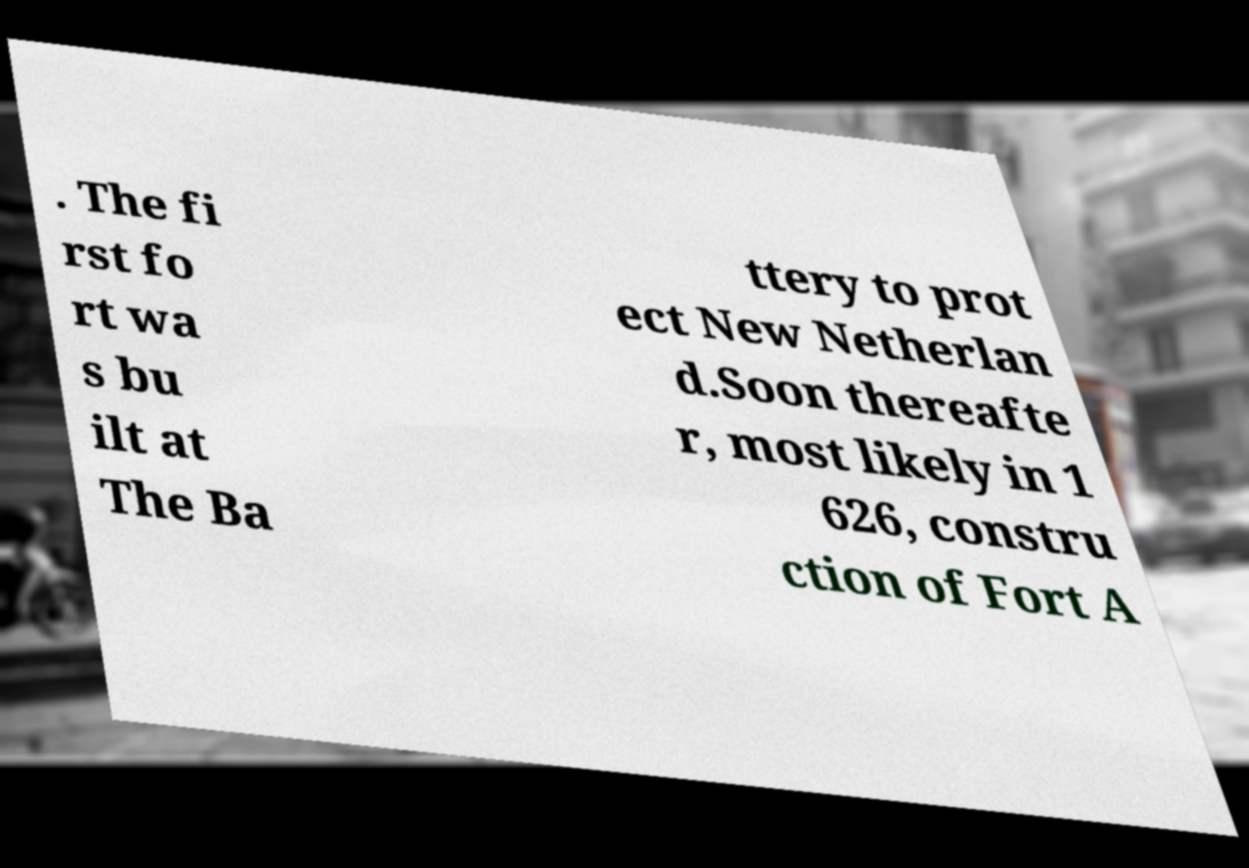There's text embedded in this image that I need extracted. Can you transcribe it verbatim? . The fi rst fo rt wa s bu ilt at The Ba ttery to prot ect New Netherlan d.Soon thereafte r, most likely in 1 626, constru ction of Fort A 